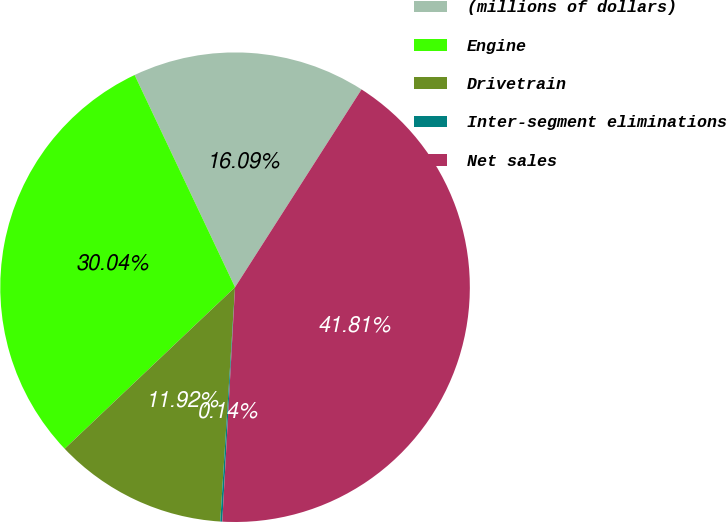Convert chart to OTSL. <chart><loc_0><loc_0><loc_500><loc_500><pie_chart><fcel>(millions of dollars)<fcel>Engine<fcel>Drivetrain<fcel>Inter-segment eliminations<fcel>Net sales<nl><fcel>16.09%<fcel>30.04%<fcel>11.92%<fcel>0.14%<fcel>41.81%<nl></chart> 